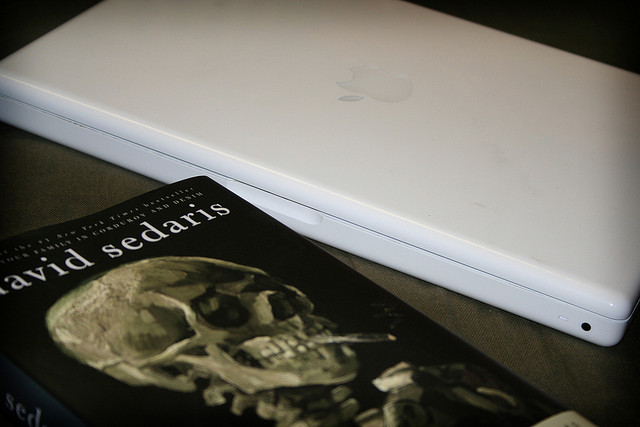<image>What is the title of this book? The title of the book is unknown or not shown. Some suggest it could be 'david sedaris' or 'engulfed in flames'. What is the title of this book? I don't know the title of this book. It could be 'David Sedaris', 'Engulfed in Flames', 'No Title', 'Not Shown', or 'God is Evil'. 